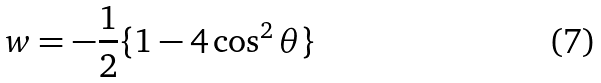Convert formula to latex. <formula><loc_0><loc_0><loc_500><loc_500>w = - \frac { 1 } { 2 } \{ 1 - 4 \cos ^ { 2 } \theta \}</formula> 